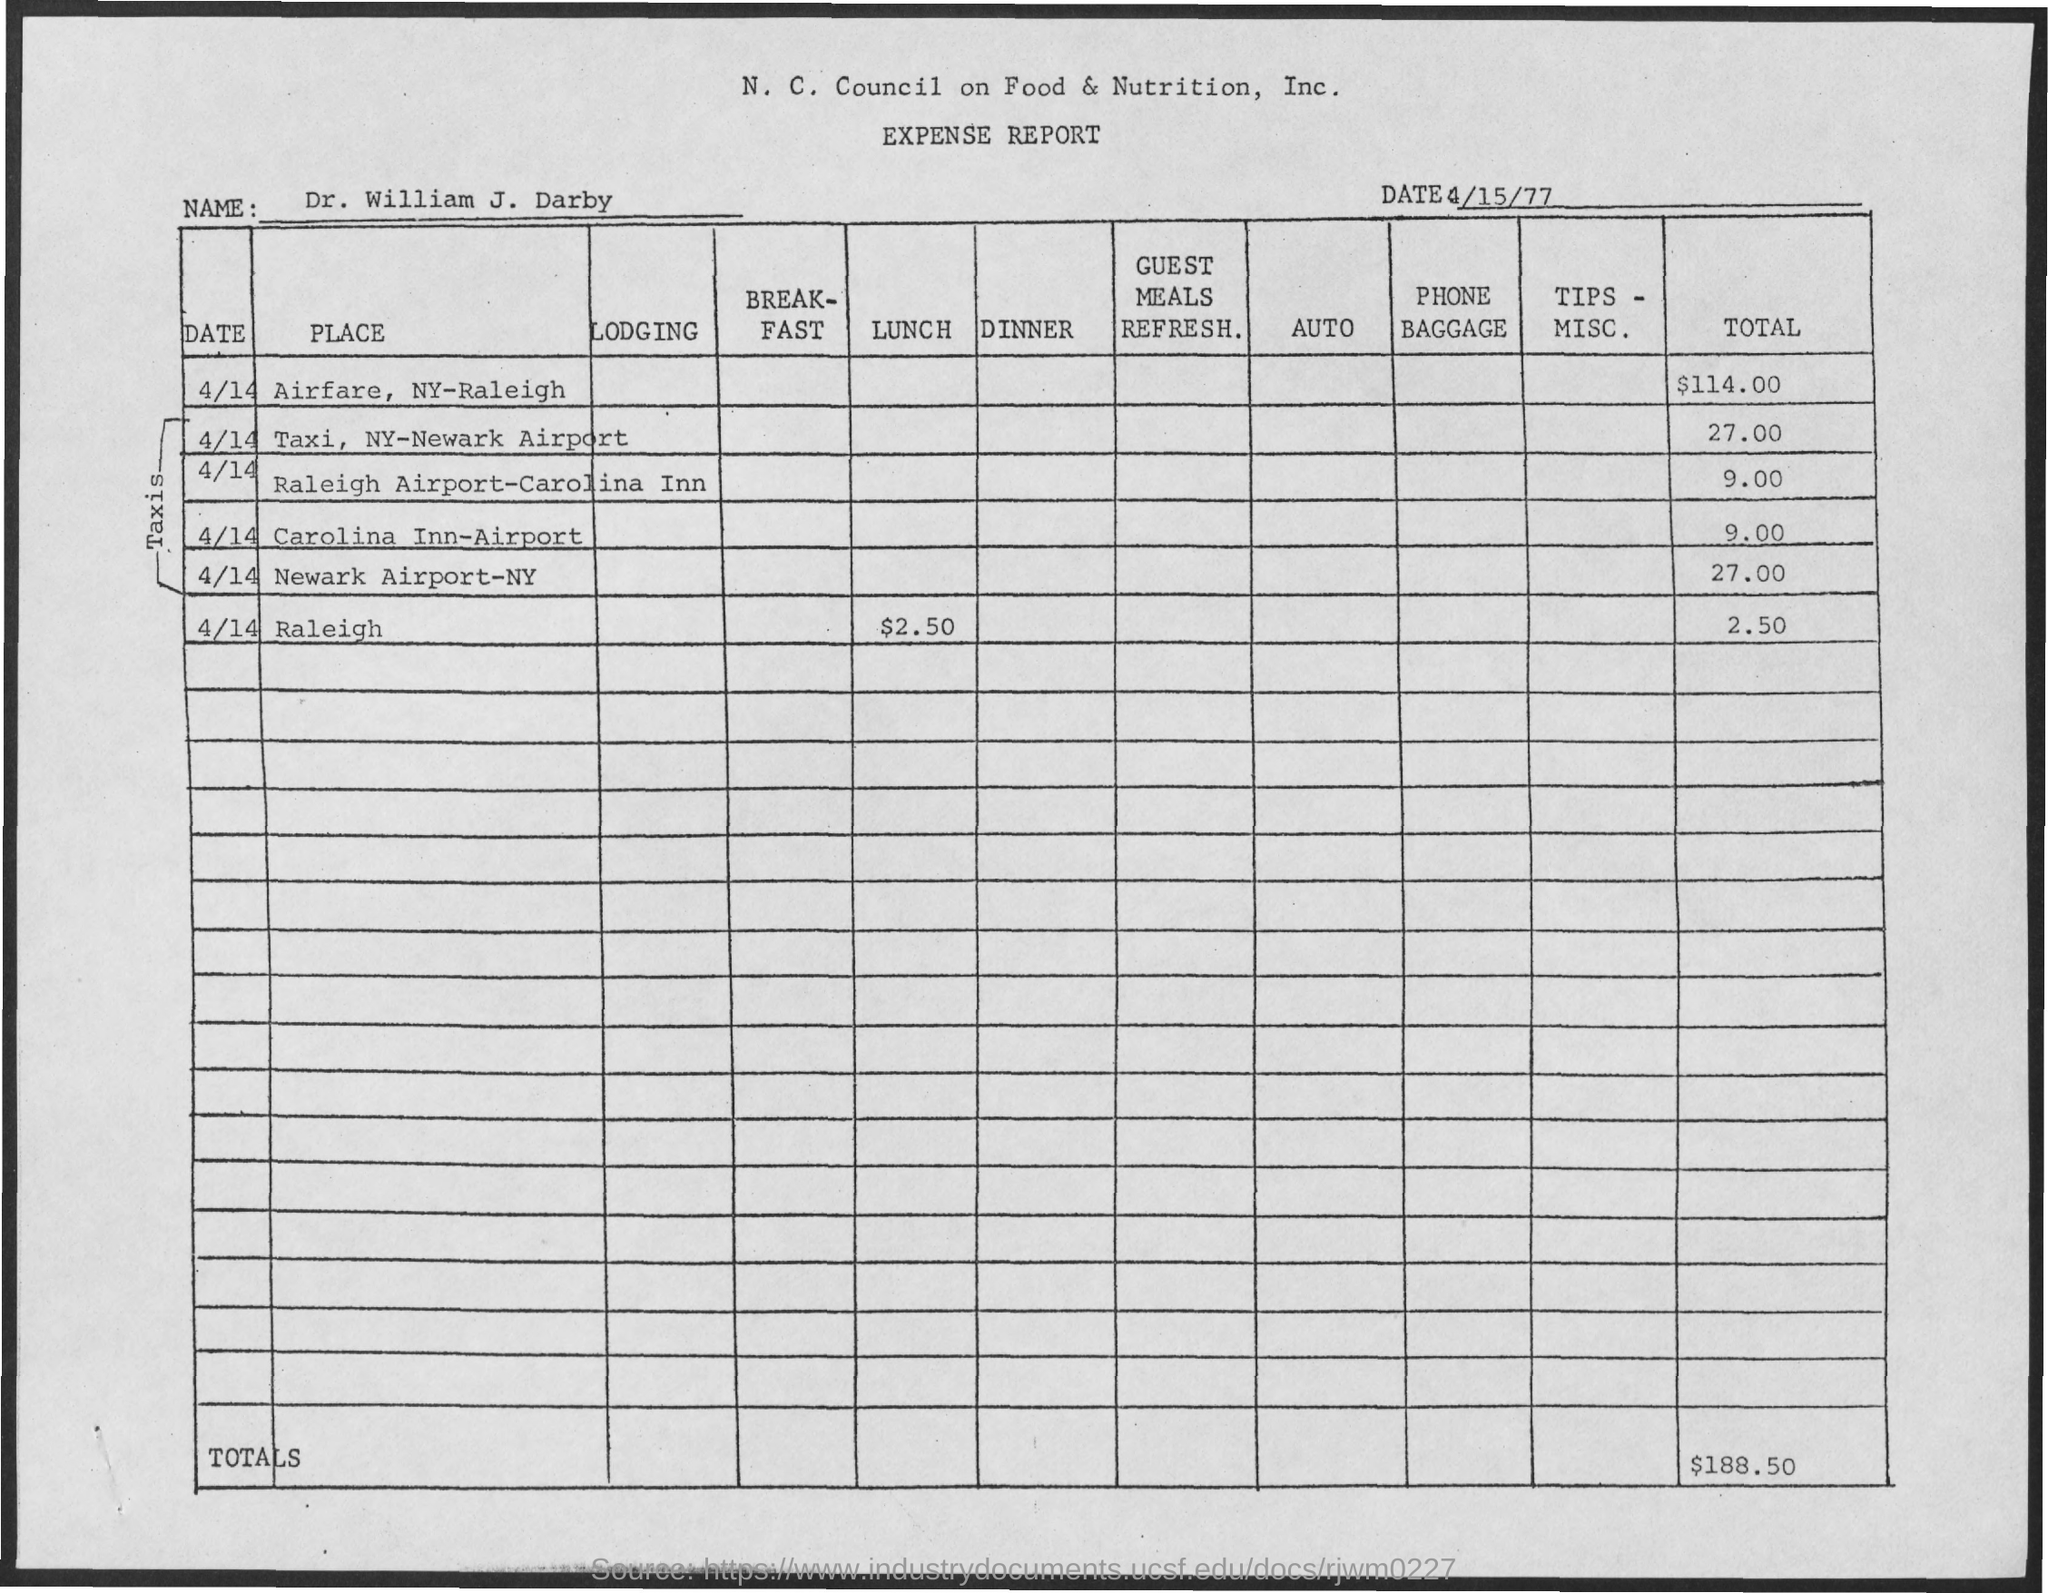Identify some key points in this picture. The total expenditure for airfare is $114.00. The total expenditure for all items is $188.50. The date of this expense report is April 15, 1977. 